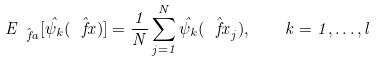<formula> <loc_0><loc_0><loc_500><loc_500>E _ { \hat { \ f a } } [ \hat { \psi } _ { k } ( \hat { \ f x } ) ] = \frac { 1 } { N } \sum _ { j = 1 } ^ { N } \hat { \psi } _ { k } ( \hat { \ f x } _ { j } ) , \quad k = 1 , \dots , l</formula> 